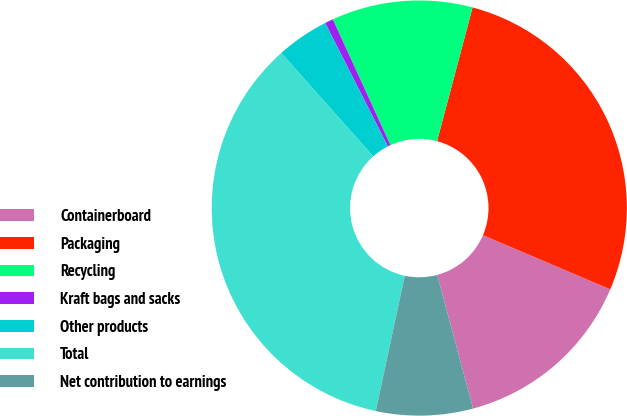<chart> <loc_0><loc_0><loc_500><loc_500><pie_chart><fcel>Containerboard<fcel>Packaging<fcel>Recycling<fcel>Kraft bags and sacks<fcel>Other products<fcel>Total<fcel>Net contribution to earnings<nl><fcel>14.42%<fcel>27.27%<fcel>10.97%<fcel>0.65%<fcel>4.09%<fcel>35.06%<fcel>7.53%<nl></chart> 